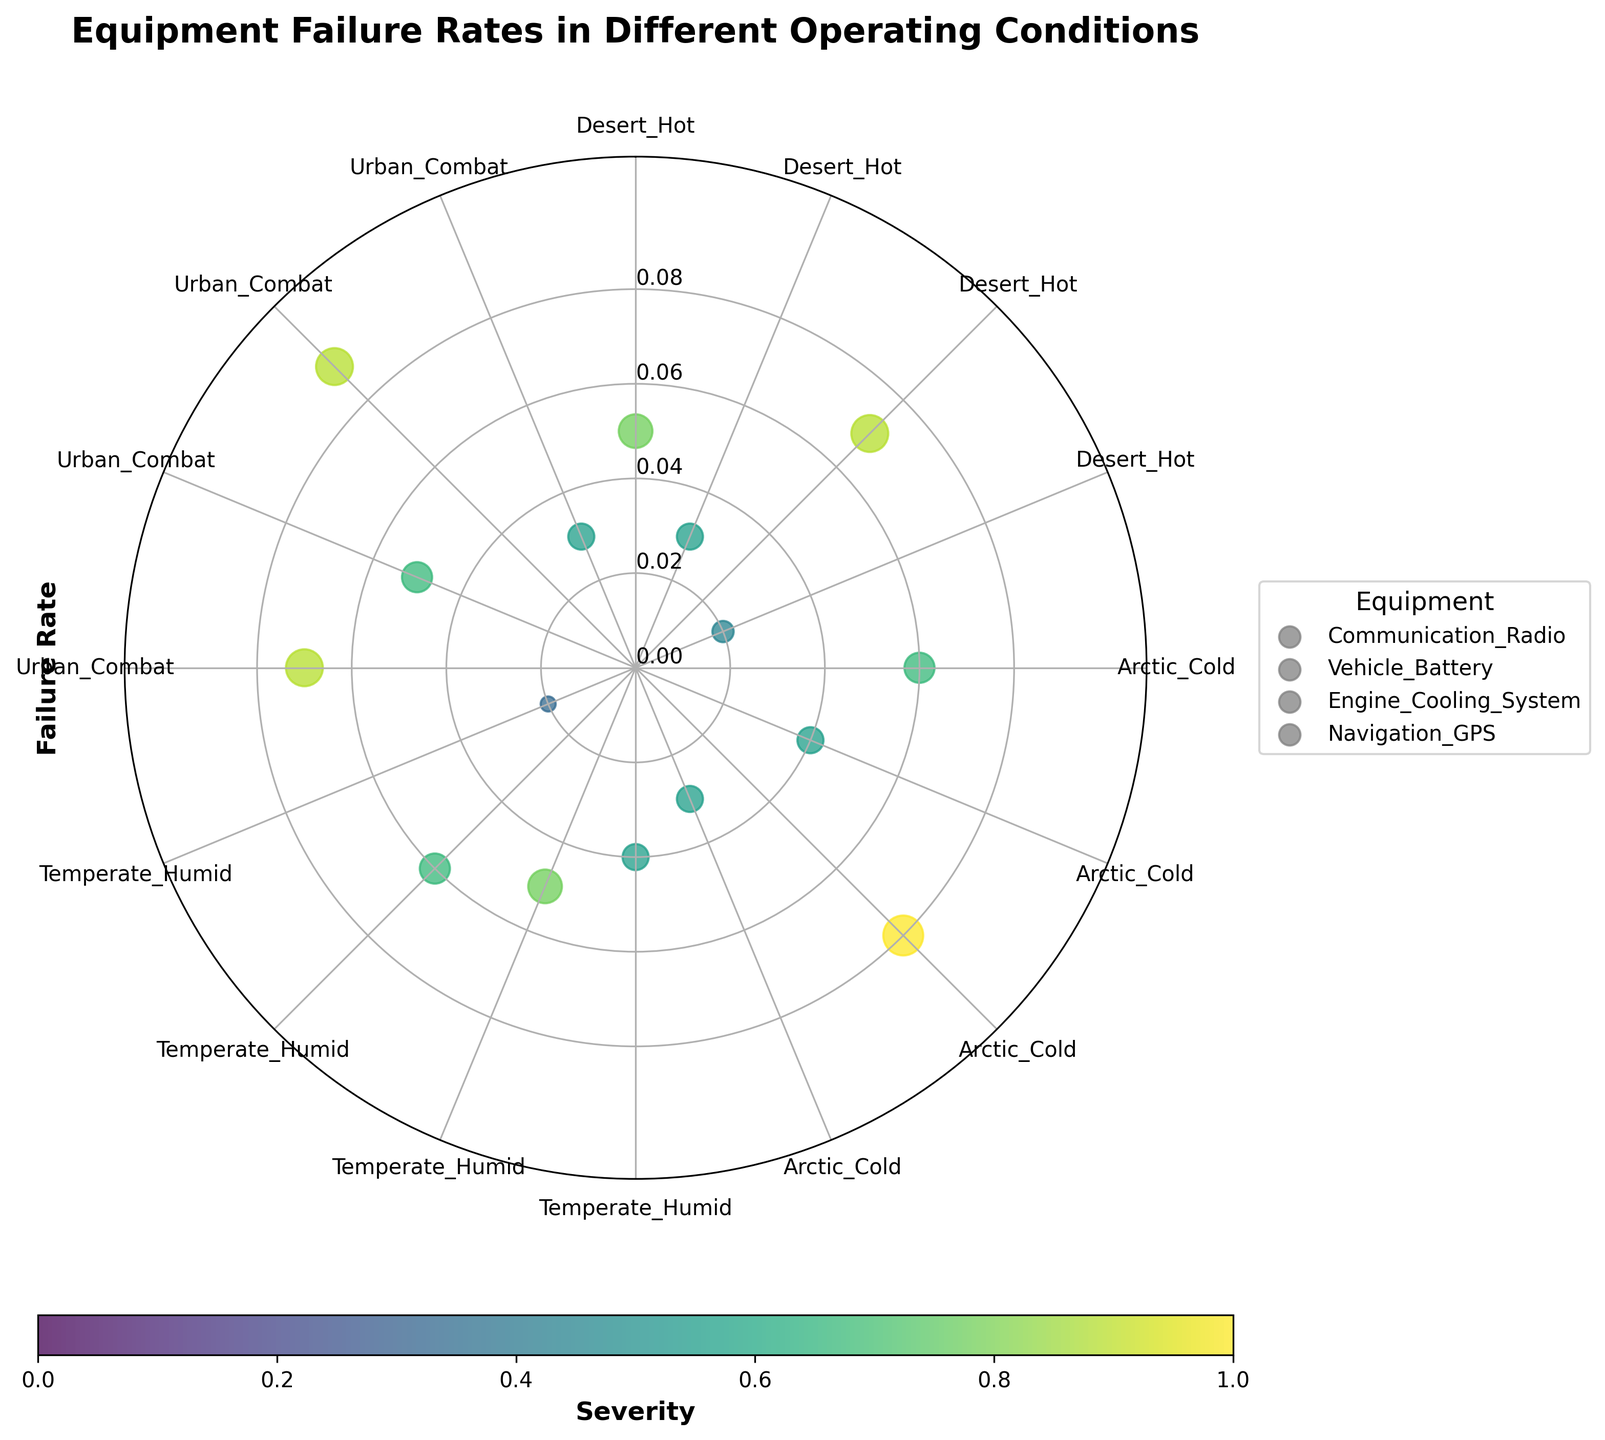How many different operating conditions are shown in the chart? Identify the number of unique sectors around the polar plot perimeter, each labeled with an operating condition. Count each unique label.
Answer: 4 Which equipment has the highest failure rate in Urban Combat conditions? Locate the Urban Combat sector and identify the data points corresponding to different equipment. Find the point with the highest radial distance (failure rate).
Answer: Engine Cooling System What is the average severity of equipment failures in Desert Hot conditions? In the Desert Hot sector, identify the severity values of all data points. Calculate the sum of these values and divide by the number of data points. (7 + 5 + 8 + 4) / 4 = 6
Answer: 6 Which operating condition has the maximum number of equipment failures? Count the number of data points in each sector corresponding to different operating conditions. Compare these counts to find the sector with the most points.
Answer: Desert Hot Are the failure rates higher in Arctic Cold conditions or Temperate Humid conditions overall? Observe the radial distances (failure rates) of all data points in Arctic Cold and Temperate Humid sectors. Compare the general trend of these distances. Arctic Cold has higher failure rates (mostly between 0.03 and 0.08).
Answer: Arctic Cold What equipment shows the least severe failures in Temperate Humid conditions? In the Temperate Humid sector, identify the data points corresponding to different equipment. Find the point with the smallest size (indicating severity).
Answer: Navigation GPS How does the severity of failures in Communication Radio compare between Arctic Cold and Urban Combat? Locate the Communication Radio data points in both Arctic Cold and Urban Combat sectors. Compare their sizes (severities). Urban Combat has a larger data point, indicating higher severity.
Answer: Urban Combat Which operating condition has the most variability in failure rates for the Engine Cooling System? Identify the Engine Cooling System data points in each sector. Observe the range of radial distances (failure rates) within each sector to determine the greatest variability.
Answer: Arctic Cold In which operating condition does Navigation GPS have the lowest failure rate? Locate the Navigation GPS data points across all sectors. Identify the point with the smallest radial distance (failure rate).
Answer: Desert Hot What equipment type has the highest overall average severity across all conditions? Calculate the average severity for each equipment type by summing the severity values for each equipment and dividing by the number of values. Compare these averages and find the highest. Engine Cooling System: (8+9+6+8)/4 = 7.75, others are lower.
Answer: Engine Cooling System 